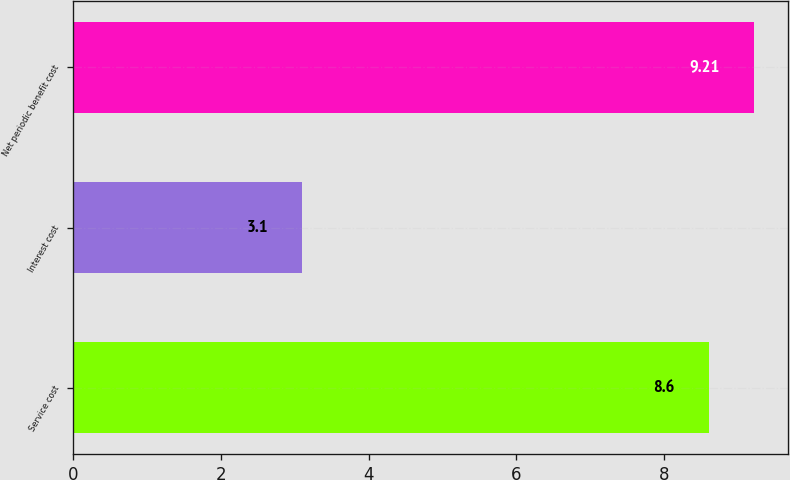Convert chart. <chart><loc_0><loc_0><loc_500><loc_500><bar_chart><fcel>Service cost<fcel>Interest cost<fcel>Net periodic benefit cost<nl><fcel>8.6<fcel>3.1<fcel>9.21<nl></chart> 